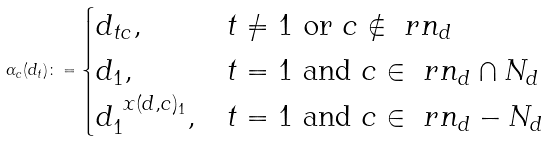Convert formula to latex. <formula><loc_0><loc_0><loc_500><loc_500>\alpha _ { c } ( d _ { t } ) \colon = \begin{cases} d _ { t c } , & t \neq 1 \text { or } c \not \in \ r n _ { d } \\ d _ { 1 } , & t = 1 \text { and } c \in \ r n _ { d } \cap N _ { d } \\ d _ { 1 } ^ { \ x ( d , c ) _ { 1 } } , & t = 1 \text { and } c \in \ r n _ { d } - N _ { d } \end{cases}</formula> 